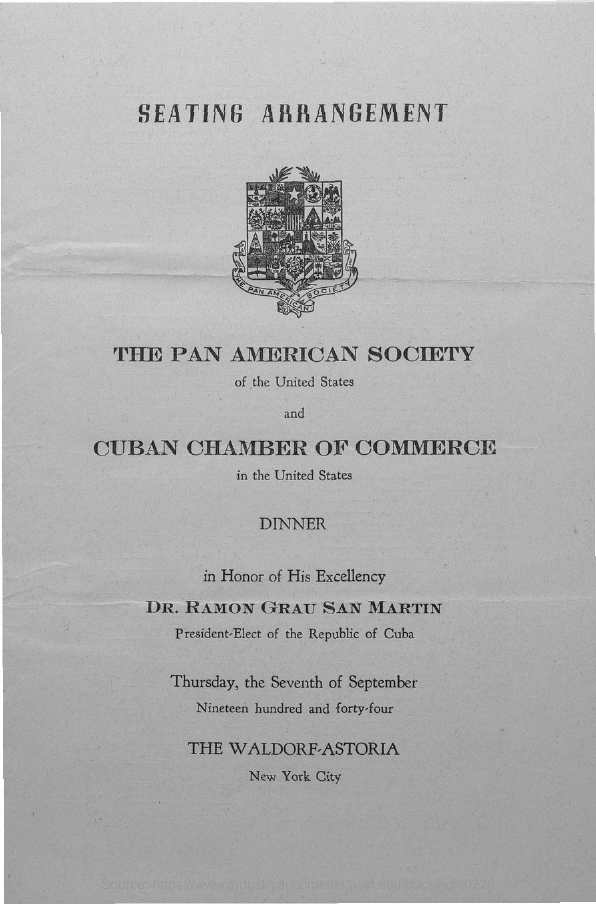What is the first title in the document?
Ensure brevity in your answer.  Seating Arrangement. 